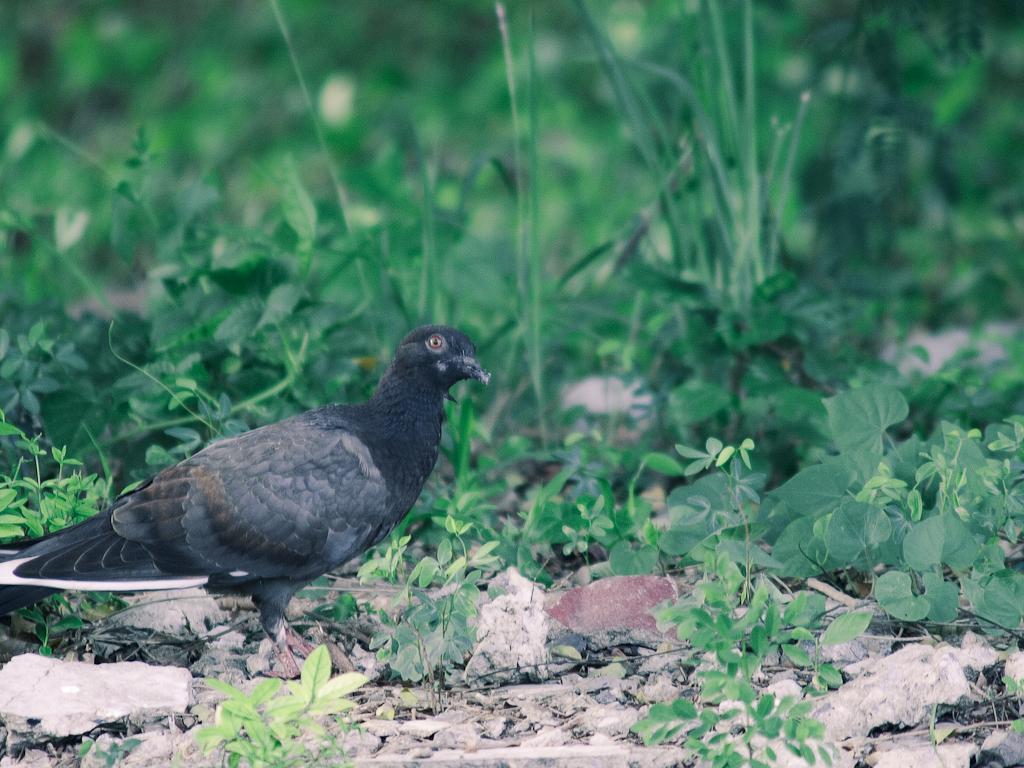How would you summarize this image in a sentence or two? In this image I can see a bird is standing on the ground. In the background I can see plants. This image is taken during a day. 